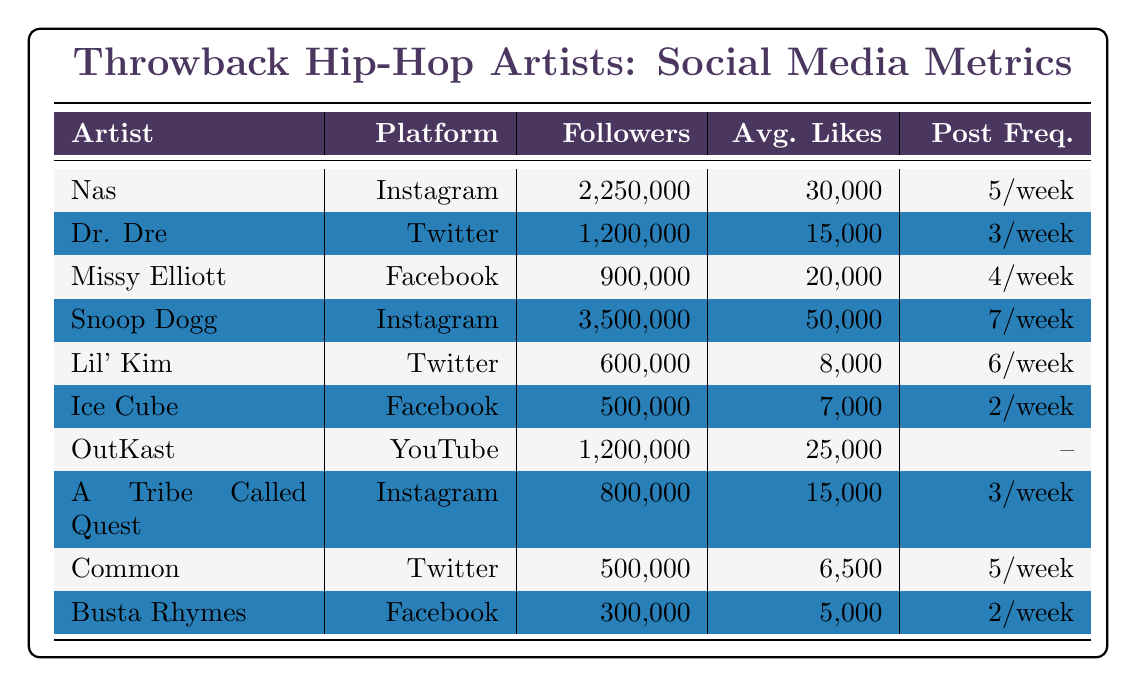What is the total number of followers for all the artists listed? To find the total number of followers, sum the followers for each artist: 2,250,000 + 1,200,000 + 900,000 + 3,500,000 + 600,000 + 500,000 + 1,200,000 + 800,000 + 500,000 + 300,000 = 12,250,000
Answer: 12,250,000 Which artist has the highest average likes per post? Compare the average likes per post for each artist: Snoop Dogg has the highest with 50,000 likes.
Answer: Snoop Dogg How many artists have a higher average likes per post than 20,000? Look at the average likes per post column: only Snoop Dogg (50,000) and Nas (30,000) have more than 20,000 likes. Thus, there are two artists.
Answer: 2 What platform does Ice Cube use? Check the platform column for Ice Cube, which shows that he uses Facebook.
Answer: Facebook Is the post frequency for Missy Elliott higher than for Busta Rhymes? Missy Elliott has a frequency of 4 posts per week and Busta Rhymes has 2. Since 4 is greater than 2, the answer is yes.
Answer: Yes Calculate the average followers for artists who primarily use Instagram. The Instagram artists are Nas (2,250,000), Snoop Dogg (3,500,000), and A Tribe Called Quest (800,000). Sum their followers: 2,250,000 + 3,500,000 + 800,000 = 6,550,000. There are 3 artists, so the average is 6,550,000 / 3 = 2,183,333.33.
Answer: 2,183,333 Which artist has the lowest average likes per post and what is that value? Review the average likes per post column to find the lowest value, which is Busta Rhymes with 5,000 likes per post.
Answer: 5,000 Is the average likes per post for Twitter artists higher than that for Facebook artists? Twitter artists' average likes: Dr. Dre (15,000), Lil' Kim (8,000), Common (6,500). Average = (15,000 + 8,000 + 6,500) / 3 = 9,166.67. Facebook artists' average likes: Missy Elliott (20,000), Ice Cube (7,000), Busta Rhymes (5,000). Average = (20,000 + 7,000 + 5,000) / 3 = 10,666.67. Comparing the two averages shows Facebook is higher.
Answer: No Count the total number of artists listed for each social media platform. There are 4 artists on Instagram (Nas, Snoop Dogg, A Tribe Called Quest), 3 on Twitter (Dr. Dre, Lil' Kim, Common), 3 on Facebook (Missy Elliott, Ice Cube, Busta Rhymes), and 1 on YouTube (OutKast). The totals are: Instagram=4, Twitter=3, Facebook=3, YouTube=1.
Answer: Instagram: 4, Twitter: 3, Facebook: 3, YouTube: 1 Which platform has the most followers in total? Sum followers for each platform: Instagram = 2,250,000 + 3,500,000 + 800,000 = 6,550,000; Twitter = 1,200,000 + 600,000 + 500,000 = 2,300,000; Facebook = 900,000 + 500,000 + 300,000 = 1,700,000; YouTube = 1,200,000. The highest total is for Instagram at 6,550,000.
Answer: Instagram 